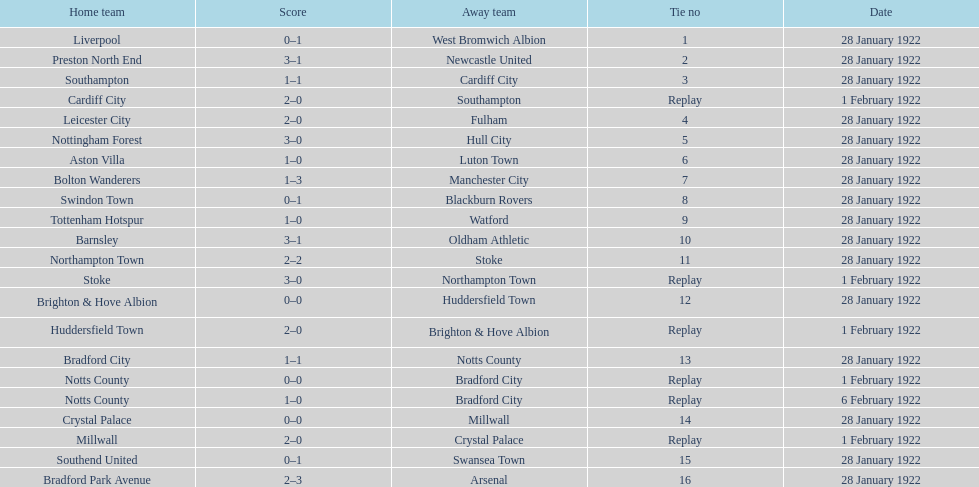What are all of the home teams? Liverpool, Preston North End, Southampton, Cardiff City, Leicester City, Nottingham Forest, Aston Villa, Bolton Wanderers, Swindon Town, Tottenham Hotspur, Barnsley, Northampton Town, Stoke, Brighton & Hove Albion, Huddersfield Town, Bradford City, Notts County, Notts County, Crystal Palace, Millwall, Southend United, Bradford Park Avenue. What were the scores? 0–1, 3–1, 1–1, 2–0, 2–0, 3–0, 1–0, 1–3, 0–1, 1–0, 3–1, 2–2, 3–0, 0–0, 2–0, 1–1, 0–0, 1–0, 0–0, 2–0, 0–1, 2–3. On which dates did they play? 28 January 1922, 28 January 1922, 28 January 1922, 1 February 1922, 28 January 1922, 28 January 1922, 28 January 1922, 28 January 1922, 28 January 1922, 28 January 1922, 28 January 1922, 28 January 1922, 1 February 1922, 28 January 1922, 1 February 1922, 28 January 1922, 1 February 1922, 6 February 1922, 28 January 1922, 1 February 1922, 28 January 1922, 28 January 1922. Which teams played on 28 january 1922? Liverpool, Preston North End, Southampton, Leicester City, Nottingham Forest, Aston Villa, Bolton Wanderers, Swindon Town, Tottenham Hotspur, Barnsley, Northampton Town, Brighton & Hove Albion, Bradford City, Crystal Palace, Southend United, Bradford Park Avenue. Of those, which scored the same as aston villa? Tottenham Hotspur. 